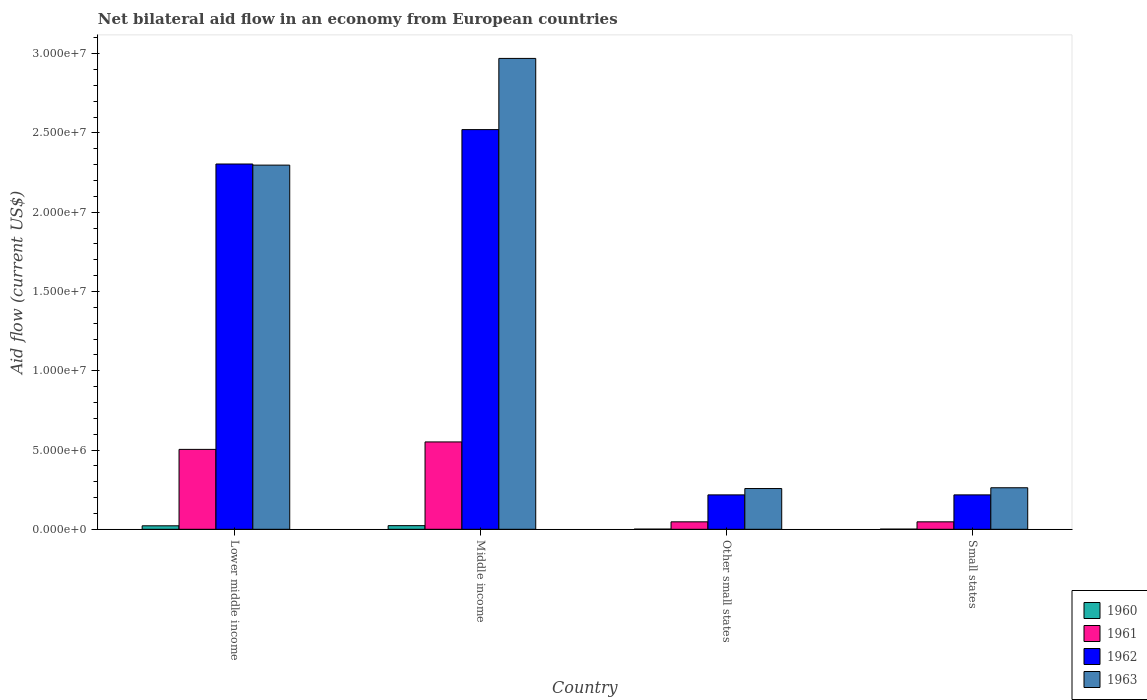How many groups of bars are there?
Provide a succinct answer. 4. Are the number of bars per tick equal to the number of legend labels?
Offer a terse response. Yes. How many bars are there on the 3rd tick from the left?
Make the answer very short. 4. How many bars are there on the 3rd tick from the right?
Provide a succinct answer. 4. What is the label of the 1st group of bars from the left?
Offer a terse response. Lower middle income. Across all countries, what is the maximum net bilateral aid flow in 1963?
Make the answer very short. 2.97e+07. In which country was the net bilateral aid flow in 1963 minimum?
Give a very brief answer. Other small states. What is the total net bilateral aid flow in 1962 in the graph?
Your answer should be compact. 5.26e+07. What is the difference between the net bilateral aid flow in 1963 in Lower middle income and that in Small states?
Keep it short and to the point. 2.04e+07. What is the difference between the net bilateral aid flow in 1963 in Other small states and the net bilateral aid flow in 1961 in Middle income?
Ensure brevity in your answer.  -2.94e+06. What is the average net bilateral aid flow in 1960 per country?
Your response must be concise. 1.18e+05. What is the difference between the net bilateral aid flow of/in 1963 and net bilateral aid flow of/in 1961 in Middle income?
Provide a short and direct response. 2.42e+07. What is the ratio of the net bilateral aid flow in 1962 in Lower middle income to that in Small states?
Make the answer very short. 10.62. Is the net bilateral aid flow in 1960 in Middle income less than that in Other small states?
Keep it short and to the point. No. What is the difference between the highest and the lowest net bilateral aid flow in 1960?
Offer a terse response. 2.20e+05. In how many countries, is the net bilateral aid flow in 1961 greater than the average net bilateral aid flow in 1961 taken over all countries?
Provide a short and direct response. 2. What does the 4th bar from the left in Middle income represents?
Provide a short and direct response. 1963. What does the 4th bar from the right in Other small states represents?
Offer a terse response. 1960. Is it the case that in every country, the sum of the net bilateral aid flow in 1962 and net bilateral aid flow in 1961 is greater than the net bilateral aid flow in 1960?
Give a very brief answer. Yes. How many bars are there?
Give a very brief answer. 16. Are all the bars in the graph horizontal?
Your answer should be compact. No. Are the values on the major ticks of Y-axis written in scientific E-notation?
Provide a succinct answer. Yes. Does the graph contain grids?
Your answer should be compact. No. Where does the legend appear in the graph?
Offer a terse response. Bottom right. How are the legend labels stacked?
Keep it short and to the point. Vertical. What is the title of the graph?
Your response must be concise. Net bilateral aid flow in an economy from European countries. What is the Aid flow (current US$) of 1961 in Lower middle income?
Make the answer very short. 5.04e+06. What is the Aid flow (current US$) of 1962 in Lower middle income?
Your response must be concise. 2.30e+07. What is the Aid flow (current US$) in 1963 in Lower middle income?
Make the answer very short. 2.30e+07. What is the Aid flow (current US$) in 1960 in Middle income?
Offer a terse response. 2.30e+05. What is the Aid flow (current US$) in 1961 in Middle income?
Keep it short and to the point. 5.51e+06. What is the Aid flow (current US$) in 1962 in Middle income?
Provide a succinct answer. 2.52e+07. What is the Aid flow (current US$) of 1963 in Middle income?
Offer a terse response. 2.97e+07. What is the Aid flow (current US$) of 1960 in Other small states?
Provide a short and direct response. 10000. What is the Aid flow (current US$) in 1962 in Other small states?
Offer a very short reply. 2.17e+06. What is the Aid flow (current US$) in 1963 in Other small states?
Give a very brief answer. 2.57e+06. What is the Aid flow (current US$) in 1960 in Small states?
Your answer should be compact. 10000. What is the Aid flow (current US$) of 1962 in Small states?
Offer a terse response. 2.17e+06. What is the Aid flow (current US$) in 1963 in Small states?
Keep it short and to the point. 2.62e+06. Across all countries, what is the maximum Aid flow (current US$) in 1961?
Ensure brevity in your answer.  5.51e+06. Across all countries, what is the maximum Aid flow (current US$) of 1962?
Keep it short and to the point. 2.52e+07. Across all countries, what is the maximum Aid flow (current US$) of 1963?
Ensure brevity in your answer.  2.97e+07. Across all countries, what is the minimum Aid flow (current US$) in 1960?
Offer a terse response. 10000. Across all countries, what is the minimum Aid flow (current US$) in 1962?
Your response must be concise. 2.17e+06. Across all countries, what is the minimum Aid flow (current US$) of 1963?
Your answer should be compact. 2.57e+06. What is the total Aid flow (current US$) of 1961 in the graph?
Offer a very short reply. 1.15e+07. What is the total Aid flow (current US$) in 1962 in the graph?
Keep it short and to the point. 5.26e+07. What is the total Aid flow (current US$) in 1963 in the graph?
Offer a very short reply. 5.79e+07. What is the difference between the Aid flow (current US$) in 1961 in Lower middle income and that in Middle income?
Offer a terse response. -4.70e+05. What is the difference between the Aid flow (current US$) of 1962 in Lower middle income and that in Middle income?
Offer a terse response. -2.17e+06. What is the difference between the Aid flow (current US$) in 1963 in Lower middle income and that in Middle income?
Keep it short and to the point. -6.73e+06. What is the difference between the Aid flow (current US$) in 1960 in Lower middle income and that in Other small states?
Ensure brevity in your answer.  2.10e+05. What is the difference between the Aid flow (current US$) in 1961 in Lower middle income and that in Other small states?
Offer a terse response. 4.57e+06. What is the difference between the Aid flow (current US$) of 1962 in Lower middle income and that in Other small states?
Ensure brevity in your answer.  2.09e+07. What is the difference between the Aid flow (current US$) of 1963 in Lower middle income and that in Other small states?
Make the answer very short. 2.04e+07. What is the difference between the Aid flow (current US$) of 1960 in Lower middle income and that in Small states?
Give a very brief answer. 2.10e+05. What is the difference between the Aid flow (current US$) of 1961 in Lower middle income and that in Small states?
Your answer should be very brief. 4.57e+06. What is the difference between the Aid flow (current US$) in 1962 in Lower middle income and that in Small states?
Your response must be concise. 2.09e+07. What is the difference between the Aid flow (current US$) in 1963 in Lower middle income and that in Small states?
Provide a short and direct response. 2.04e+07. What is the difference between the Aid flow (current US$) of 1960 in Middle income and that in Other small states?
Offer a very short reply. 2.20e+05. What is the difference between the Aid flow (current US$) of 1961 in Middle income and that in Other small states?
Your response must be concise. 5.04e+06. What is the difference between the Aid flow (current US$) in 1962 in Middle income and that in Other small states?
Make the answer very short. 2.30e+07. What is the difference between the Aid flow (current US$) in 1963 in Middle income and that in Other small states?
Provide a short and direct response. 2.71e+07. What is the difference between the Aid flow (current US$) in 1960 in Middle income and that in Small states?
Keep it short and to the point. 2.20e+05. What is the difference between the Aid flow (current US$) of 1961 in Middle income and that in Small states?
Provide a short and direct response. 5.04e+06. What is the difference between the Aid flow (current US$) in 1962 in Middle income and that in Small states?
Provide a short and direct response. 2.30e+07. What is the difference between the Aid flow (current US$) in 1963 in Middle income and that in Small states?
Offer a terse response. 2.71e+07. What is the difference between the Aid flow (current US$) in 1961 in Other small states and that in Small states?
Provide a succinct answer. 0. What is the difference between the Aid flow (current US$) of 1963 in Other small states and that in Small states?
Keep it short and to the point. -5.00e+04. What is the difference between the Aid flow (current US$) in 1960 in Lower middle income and the Aid flow (current US$) in 1961 in Middle income?
Provide a short and direct response. -5.29e+06. What is the difference between the Aid flow (current US$) of 1960 in Lower middle income and the Aid flow (current US$) of 1962 in Middle income?
Provide a short and direct response. -2.50e+07. What is the difference between the Aid flow (current US$) in 1960 in Lower middle income and the Aid flow (current US$) in 1963 in Middle income?
Provide a short and direct response. -2.95e+07. What is the difference between the Aid flow (current US$) in 1961 in Lower middle income and the Aid flow (current US$) in 1962 in Middle income?
Your response must be concise. -2.02e+07. What is the difference between the Aid flow (current US$) in 1961 in Lower middle income and the Aid flow (current US$) in 1963 in Middle income?
Your response must be concise. -2.47e+07. What is the difference between the Aid flow (current US$) of 1962 in Lower middle income and the Aid flow (current US$) of 1963 in Middle income?
Offer a terse response. -6.66e+06. What is the difference between the Aid flow (current US$) of 1960 in Lower middle income and the Aid flow (current US$) of 1961 in Other small states?
Provide a short and direct response. -2.50e+05. What is the difference between the Aid flow (current US$) of 1960 in Lower middle income and the Aid flow (current US$) of 1962 in Other small states?
Offer a very short reply. -1.95e+06. What is the difference between the Aid flow (current US$) in 1960 in Lower middle income and the Aid flow (current US$) in 1963 in Other small states?
Make the answer very short. -2.35e+06. What is the difference between the Aid flow (current US$) of 1961 in Lower middle income and the Aid flow (current US$) of 1962 in Other small states?
Offer a terse response. 2.87e+06. What is the difference between the Aid flow (current US$) of 1961 in Lower middle income and the Aid flow (current US$) of 1963 in Other small states?
Offer a very short reply. 2.47e+06. What is the difference between the Aid flow (current US$) of 1962 in Lower middle income and the Aid flow (current US$) of 1963 in Other small states?
Your answer should be compact. 2.05e+07. What is the difference between the Aid flow (current US$) of 1960 in Lower middle income and the Aid flow (current US$) of 1962 in Small states?
Ensure brevity in your answer.  -1.95e+06. What is the difference between the Aid flow (current US$) in 1960 in Lower middle income and the Aid flow (current US$) in 1963 in Small states?
Your response must be concise. -2.40e+06. What is the difference between the Aid flow (current US$) of 1961 in Lower middle income and the Aid flow (current US$) of 1962 in Small states?
Give a very brief answer. 2.87e+06. What is the difference between the Aid flow (current US$) of 1961 in Lower middle income and the Aid flow (current US$) of 1963 in Small states?
Offer a very short reply. 2.42e+06. What is the difference between the Aid flow (current US$) in 1962 in Lower middle income and the Aid flow (current US$) in 1963 in Small states?
Keep it short and to the point. 2.04e+07. What is the difference between the Aid flow (current US$) in 1960 in Middle income and the Aid flow (current US$) in 1961 in Other small states?
Offer a very short reply. -2.40e+05. What is the difference between the Aid flow (current US$) of 1960 in Middle income and the Aid flow (current US$) of 1962 in Other small states?
Offer a terse response. -1.94e+06. What is the difference between the Aid flow (current US$) of 1960 in Middle income and the Aid flow (current US$) of 1963 in Other small states?
Your answer should be compact. -2.34e+06. What is the difference between the Aid flow (current US$) of 1961 in Middle income and the Aid flow (current US$) of 1962 in Other small states?
Your response must be concise. 3.34e+06. What is the difference between the Aid flow (current US$) of 1961 in Middle income and the Aid flow (current US$) of 1963 in Other small states?
Keep it short and to the point. 2.94e+06. What is the difference between the Aid flow (current US$) of 1962 in Middle income and the Aid flow (current US$) of 1963 in Other small states?
Your answer should be compact. 2.26e+07. What is the difference between the Aid flow (current US$) of 1960 in Middle income and the Aid flow (current US$) of 1962 in Small states?
Ensure brevity in your answer.  -1.94e+06. What is the difference between the Aid flow (current US$) of 1960 in Middle income and the Aid flow (current US$) of 1963 in Small states?
Provide a short and direct response. -2.39e+06. What is the difference between the Aid flow (current US$) of 1961 in Middle income and the Aid flow (current US$) of 1962 in Small states?
Give a very brief answer. 3.34e+06. What is the difference between the Aid flow (current US$) in 1961 in Middle income and the Aid flow (current US$) in 1963 in Small states?
Offer a terse response. 2.89e+06. What is the difference between the Aid flow (current US$) in 1962 in Middle income and the Aid flow (current US$) in 1963 in Small states?
Provide a short and direct response. 2.26e+07. What is the difference between the Aid flow (current US$) of 1960 in Other small states and the Aid flow (current US$) of 1961 in Small states?
Make the answer very short. -4.60e+05. What is the difference between the Aid flow (current US$) in 1960 in Other small states and the Aid flow (current US$) in 1962 in Small states?
Your answer should be compact. -2.16e+06. What is the difference between the Aid flow (current US$) of 1960 in Other small states and the Aid flow (current US$) of 1963 in Small states?
Offer a very short reply. -2.61e+06. What is the difference between the Aid flow (current US$) in 1961 in Other small states and the Aid flow (current US$) in 1962 in Small states?
Offer a very short reply. -1.70e+06. What is the difference between the Aid flow (current US$) of 1961 in Other small states and the Aid flow (current US$) of 1963 in Small states?
Your response must be concise. -2.15e+06. What is the difference between the Aid flow (current US$) of 1962 in Other small states and the Aid flow (current US$) of 1963 in Small states?
Your response must be concise. -4.50e+05. What is the average Aid flow (current US$) in 1960 per country?
Provide a succinct answer. 1.18e+05. What is the average Aid flow (current US$) in 1961 per country?
Your answer should be compact. 2.87e+06. What is the average Aid flow (current US$) in 1962 per country?
Offer a terse response. 1.31e+07. What is the average Aid flow (current US$) in 1963 per country?
Your answer should be compact. 1.45e+07. What is the difference between the Aid flow (current US$) of 1960 and Aid flow (current US$) of 1961 in Lower middle income?
Your response must be concise. -4.82e+06. What is the difference between the Aid flow (current US$) in 1960 and Aid flow (current US$) in 1962 in Lower middle income?
Ensure brevity in your answer.  -2.28e+07. What is the difference between the Aid flow (current US$) in 1960 and Aid flow (current US$) in 1963 in Lower middle income?
Offer a terse response. -2.28e+07. What is the difference between the Aid flow (current US$) in 1961 and Aid flow (current US$) in 1962 in Lower middle income?
Your answer should be very brief. -1.80e+07. What is the difference between the Aid flow (current US$) of 1961 and Aid flow (current US$) of 1963 in Lower middle income?
Ensure brevity in your answer.  -1.79e+07. What is the difference between the Aid flow (current US$) of 1960 and Aid flow (current US$) of 1961 in Middle income?
Ensure brevity in your answer.  -5.28e+06. What is the difference between the Aid flow (current US$) of 1960 and Aid flow (current US$) of 1962 in Middle income?
Provide a succinct answer. -2.50e+07. What is the difference between the Aid flow (current US$) of 1960 and Aid flow (current US$) of 1963 in Middle income?
Ensure brevity in your answer.  -2.95e+07. What is the difference between the Aid flow (current US$) in 1961 and Aid flow (current US$) in 1962 in Middle income?
Offer a terse response. -1.97e+07. What is the difference between the Aid flow (current US$) in 1961 and Aid flow (current US$) in 1963 in Middle income?
Offer a terse response. -2.42e+07. What is the difference between the Aid flow (current US$) of 1962 and Aid flow (current US$) of 1963 in Middle income?
Your answer should be compact. -4.49e+06. What is the difference between the Aid flow (current US$) of 1960 and Aid flow (current US$) of 1961 in Other small states?
Your answer should be very brief. -4.60e+05. What is the difference between the Aid flow (current US$) in 1960 and Aid flow (current US$) in 1962 in Other small states?
Ensure brevity in your answer.  -2.16e+06. What is the difference between the Aid flow (current US$) in 1960 and Aid flow (current US$) in 1963 in Other small states?
Provide a short and direct response. -2.56e+06. What is the difference between the Aid flow (current US$) of 1961 and Aid flow (current US$) of 1962 in Other small states?
Make the answer very short. -1.70e+06. What is the difference between the Aid flow (current US$) in 1961 and Aid flow (current US$) in 1963 in Other small states?
Make the answer very short. -2.10e+06. What is the difference between the Aid flow (current US$) in 1962 and Aid flow (current US$) in 1963 in Other small states?
Offer a terse response. -4.00e+05. What is the difference between the Aid flow (current US$) of 1960 and Aid flow (current US$) of 1961 in Small states?
Give a very brief answer. -4.60e+05. What is the difference between the Aid flow (current US$) in 1960 and Aid flow (current US$) in 1962 in Small states?
Your response must be concise. -2.16e+06. What is the difference between the Aid flow (current US$) of 1960 and Aid flow (current US$) of 1963 in Small states?
Your answer should be very brief. -2.61e+06. What is the difference between the Aid flow (current US$) in 1961 and Aid flow (current US$) in 1962 in Small states?
Offer a very short reply. -1.70e+06. What is the difference between the Aid flow (current US$) of 1961 and Aid flow (current US$) of 1963 in Small states?
Ensure brevity in your answer.  -2.15e+06. What is the difference between the Aid flow (current US$) in 1962 and Aid flow (current US$) in 1963 in Small states?
Offer a terse response. -4.50e+05. What is the ratio of the Aid flow (current US$) of 1960 in Lower middle income to that in Middle income?
Ensure brevity in your answer.  0.96. What is the ratio of the Aid flow (current US$) in 1961 in Lower middle income to that in Middle income?
Provide a short and direct response. 0.91. What is the ratio of the Aid flow (current US$) in 1962 in Lower middle income to that in Middle income?
Ensure brevity in your answer.  0.91. What is the ratio of the Aid flow (current US$) of 1963 in Lower middle income to that in Middle income?
Provide a succinct answer. 0.77. What is the ratio of the Aid flow (current US$) in 1961 in Lower middle income to that in Other small states?
Provide a succinct answer. 10.72. What is the ratio of the Aid flow (current US$) of 1962 in Lower middle income to that in Other small states?
Your response must be concise. 10.62. What is the ratio of the Aid flow (current US$) of 1963 in Lower middle income to that in Other small states?
Your answer should be compact. 8.94. What is the ratio of the Aid flow (current US$) in 1961 in Lower middle income to that in Small states?
Provide a succinct answer. 10.72. What is the ratio of the Aid flow (current US$) in 1962 in Lower middle income to that in Small states?
Your answer should be very brief. 10.62. What is the ratio of the Aid flow (current US$) of 1963 in Lower middle income to that in Small states?
Ensure brevity in your answer.  8.77. What is the ratio of the Aid flow (current US$) of 1960 in Middle income to that in Other small states?
Ensure brevity in your answer.  23. What is the ratio of the Aid flow (current US$) in 1961 in Middle income to that in Other small states?
Make the answer very short. 11.72. What is the ratio of the Aid flow (current US$) of 1962 in Middle income to that in Other small states?
Keep it short and to the point. 11.62. What is the ratio of the Aid flow (current US$) of 1963 in Middle income to that in Other small states?
Your response must be concise. 11.56. What is the ratio of the Aid flow (current US$) in 1961 in Middle income to that in Small states?
Your answer should be very brief. 11.72. What is the ratio of the Aid flow (current US$) of 1962 in Middle income to that in Small states?
Offer a terse response. 11.62. What is the ratio of the Aid flow (current US$) of 1963 in Middle income to that in Small states?
Give a very brief answer. 11.34. What is the ratio of the Aid flow (current US$) of 1960 in Other small states to that in Small states?
Provide a short and direct response. 1. What is the ratio of the Aid flow (current US$) in 1963 in Other small states to that in Small states?
Your answer should be compact. 0.98. What is the difference between the highest and the second highest Aid flow (current US$) of 1960?
Offer a very short reply. 10000. What is the difference between the highest and the second highest Aid flow (current US$) of 1962?
Make the answer very short. 2.17e+06. What is the difference between the highest and the second highest Aid flow (current US$) in 1963?
Your answer should be compact. 6.73e+06. What is the difference between the highest and the lowest Aid flow (current US$) of 1960?
Provide a succinct answer. 2.20e+05. What is the difference between the highest and the lowest Aid flow (current US$) in 1961?
Your answer should be very brief. 5.04e+06. What is the difference between the highest and the lowest Aid flow (current US$) in 1962?
Ensure brevity in your answer.  2.30e+07. What is the difference between the highest and the lowest Aid flow (current US$) in 1963?
Give a very brief answer. 2.71e+07. 